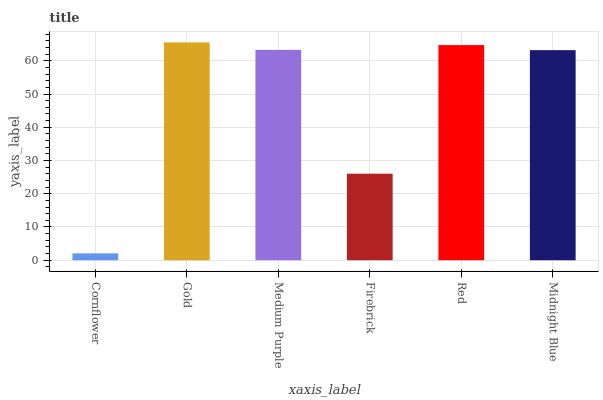Is Cornflower the minimum?
Answer yes or no. Yes. Is Gold the maximum?
Answer yes or no. Yes. Is Medium Purple the minimum?
Answer yes or no. No. Is Medium Purple the maximum?
Answer yes or no. No. Is Gold greater than Medium Purple?
Answer yes or no. Yes. Is Medium Purple less than Gold?
Answer yes or no. Yes. Is Medium Purple greater than Gold?
Answer yes or no. No. Is Gold less than Medium Purple?
Answer yes or no. No. Is Medium Purple the high median?
Answer yes or no. Yes. Is Midnight Blue the low median?
Answer yes or no. Yes. Is Cornflower the high median?
Answer yes or no. No. Is Firebrick the low median?
Answer yes or no. No. 